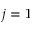Convert formula to latex. <formula><loc_0><loc_0><loc_500><loc_500>j = 1</formula> 